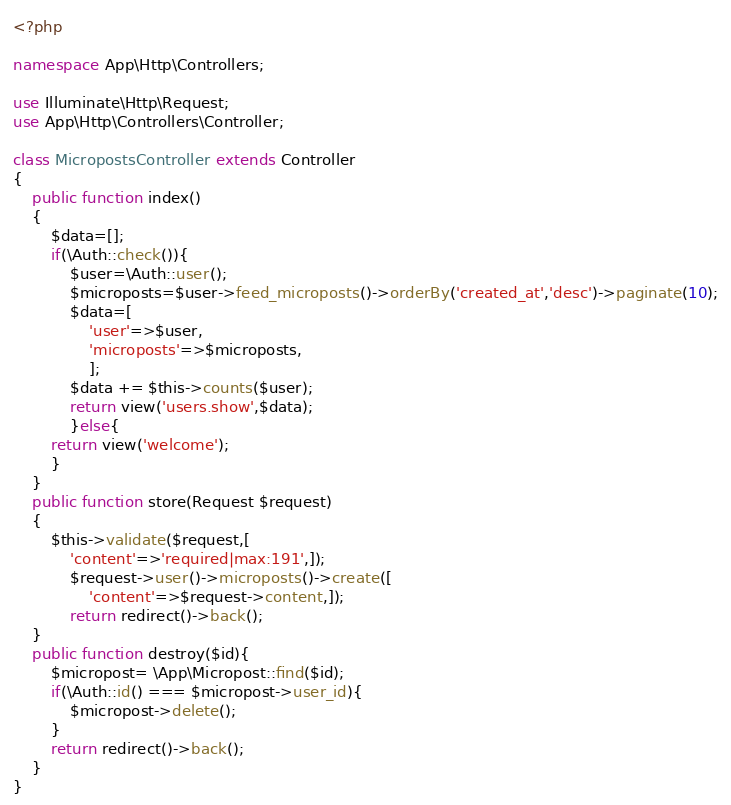<code> <loc_0><loc_0><loc_500><loc_500><_PHP_><?php

namespace App\Http\Controllers;

use Illuminate\Http\Request;
use App\Http\Controllers\Controller;

class MicropostsController extends Controller
{
    public function index()
    {
        $data=[];
        if(\Auth::check()){
            $user=\Auth::user();
            $microposts=$user->feed_microposts()->orderBy('created_at','desc')->paginate(10);
            $data=[
                'user'=>$user,
                'microposts'=>$microposts,
                ];
            $data += $this->counts($user);
            return view('users.show',$data);
            }else{ 
        return view('welcome');
        }
    }
    public function store(Request $request)
    {
        $this->validate($request,[
            'content'=>'required|max:191',]);
            $request->user()->microposts()->create([
                'content'=>$request->content,]);
            return redirect()->back();
    }
    public function destroy($id){
        $micropost= \App\Micropost::find($id);
        if(\Auth::id() === $micropost->user_id){
            $micropost->delete();
        }
        return redirect()->back();
    }
}
</code> 